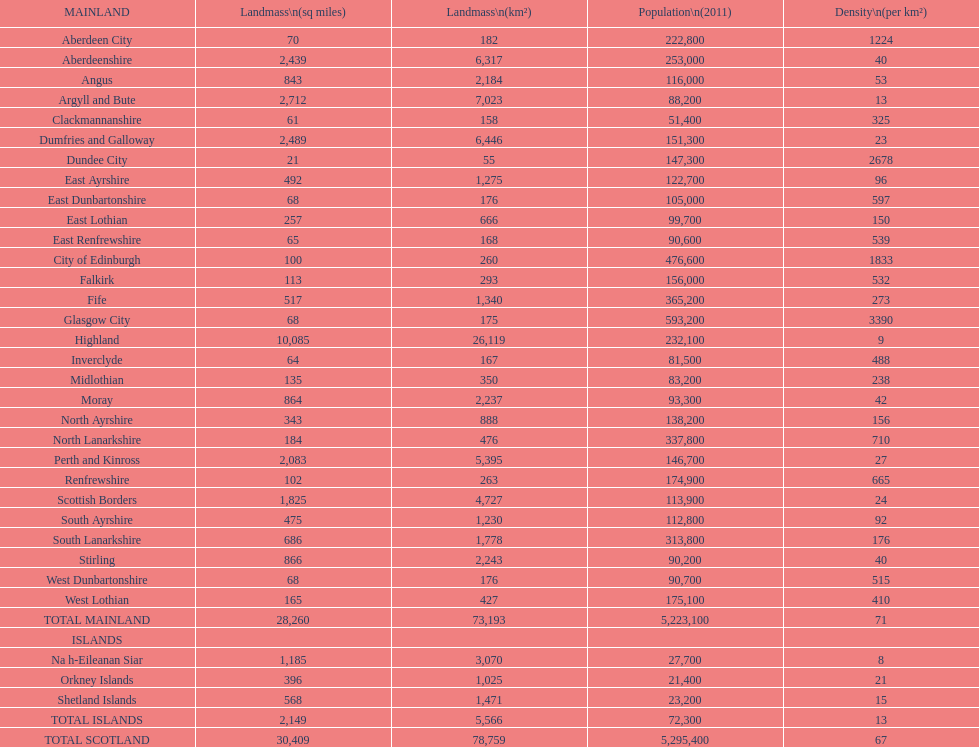Parse the table in full. {'header': ['MAINLAND', 'Landmass\\n(sq miles)', 'Landmass\\n(km²)', 'Population\\n(2011)', 'Density\\n(per km²)'], 'rows': [['Aberdeen City', '70', '182', '222,800', '1224'], ['Aberdeenshire', '2,439', '6,317', '253,000', '40'], ['Angus', '843', '2,184', '116,000', '53'], ['Argyll and Bute', '2,712', '7,023', '88,200', '13'], ['Clackmannanshire', '61', '158', '51,400', '325'], ['Dumfries and Galloway', '2,489', '6,446', '151,300', '23'], ['Dundee City', '21', '55', '147,300', '2678'], ['East Ayrshire', '492', '1,275', '122,700', '96'], ['East Dunbartonshire', '68', '176', '105,000', '597'], ['East Lothian', '257', '666', '99,700', '150'], ['East Renfrewshire', '65', '168', '90,600', '539'], ['City of Edinburgh', '100', '260', '476,600', '1833'], ['Falkirk', '113', '293', '156,000', '532'], ['Fife', '517', '1,340', '365,200', '273'], ['Glasgow City', '68', '175', '593,200', '3390'], ['Highland', '10,085', '26,119', '232,100', '9'], ['Inverclyde', '64', '167', '81,500', '488'], ['Midlothian', '135', '350', '83,200', '238'], ['Moray', '864', '2,237', '93,300', '42'], ['North Ayrshire', '343', '888', '138,200', '156'], ['North Lanarkshire', '184', '476', '337,800', '710'], ['Perth and Kinross', '2,083', '5,395', '146,700', '27'], ['Renfrewshire', '102', '263', '174,900', '665'], ['Scottish Borders', '1,825', '4,727', '113,900', '24'], ['South Ayrshire', '475', '1,230', '112,800', '92'], ['South Lanarkshire', '686', '1,778', '313,800', '176'], ['Stirling', '866', '2,243', '90,200', '40'], ['West Dunbartonshire', '68', '176', '90,700', '515'], ['West Lothian', '165', '427', '175,100', '410'], ['TOTAL MAINLAND', '28,260', '73,193', '5,223,100', '71'], ['ISLANDS', '', '', '', ''], ['Na h-Eileanan Siar', '1,185', '3,070', '27,700', '8'], ['Orkney Islands', '396', '1,025', '21,400', '21'], ['Shetland Islands', '568', '1,471', '23,200', '15'], ['TOTAL ISLANDS', '2,149', '5,566', '72,300', '13'], ['TOTAL SCOTLAND', '30,409', '78,759', '5,295,400', '67']]} What is the number of people living in angus in 2011? 116,000. 